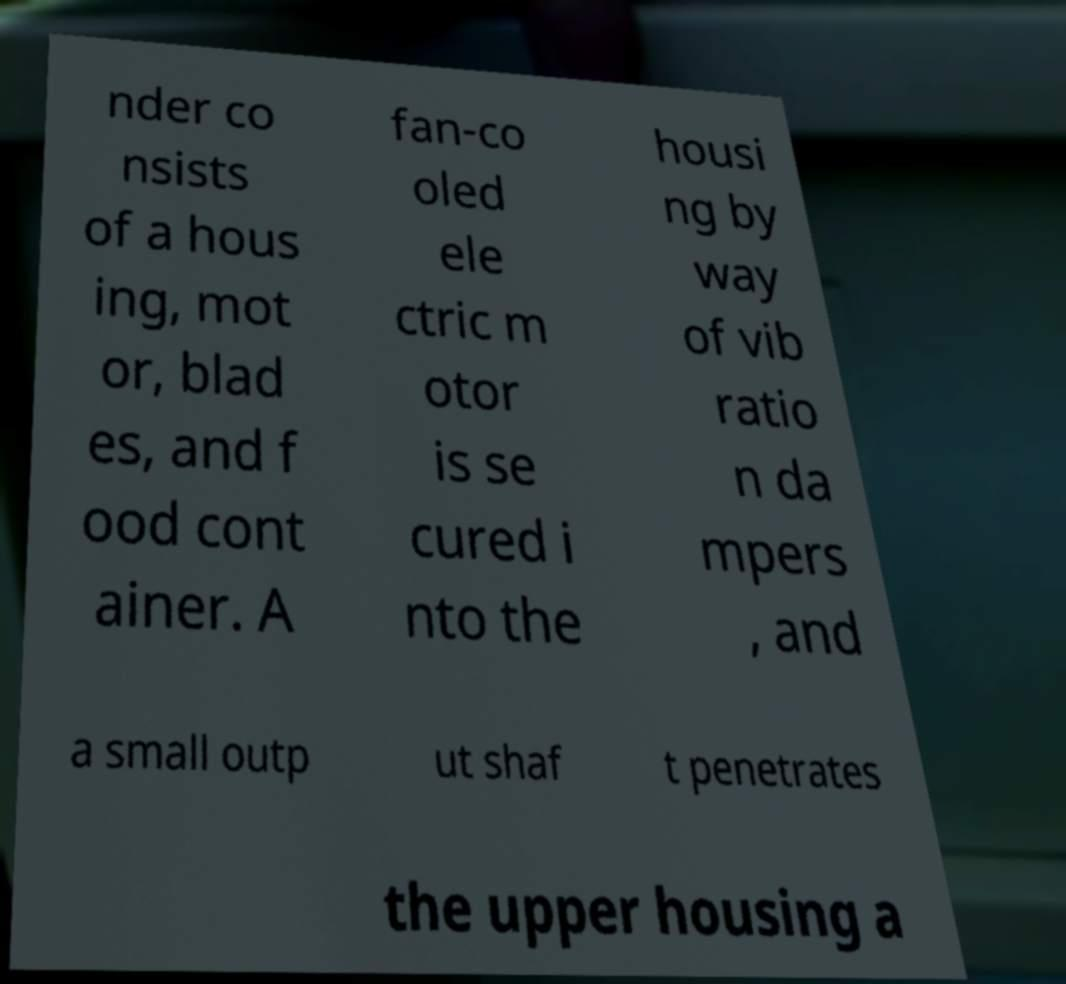I need the written content from this picture converted into text. Can you do that? nder co nsists of a hous ing, mot or, blad es, and f ood cont ainer. A fan-co oled ele ctric m otor is se cured i nto the housi ng by way of vib ratio n da mpers , and a small outp ut shaf t penetrates the upper housing a 